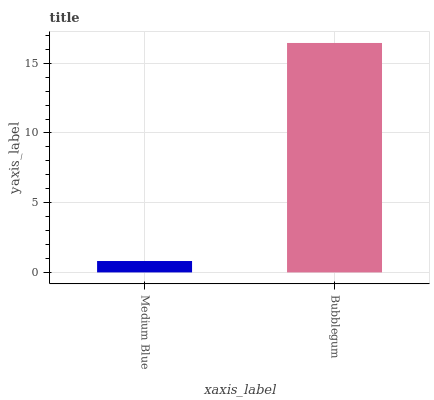Is Medium Blue the minimum?
Answer yes or no. Yes. Is Bubblegum the maximum?
Answer yes or no. Yes. Is Bubblegum the minimum?
Answer yes or no. No. Is Bubblegum greater than Medium Blue?
Answer yes or no. Yes. Is Medium Blue less than Bubblegum?
Answer yes or no. Yes. Is Medium Blue greater than Bubblegum?
Answer yes or no. No. Is Bubblegum less than Medium Blue?
Answer yes or no. No. Is Bubblegum the high median?
Answer yes or no. Yes. Is Medium Blue the low median?
Answer yes or no. Yes. Is Medium Blue the high median?
Answer yes or no. No. Is Bubblegum the low median?
Answer yes or no. No. 